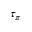<formula> <loc_0><loc_0><loc_500><loc_500>\tau _ { \pi }</formula> 